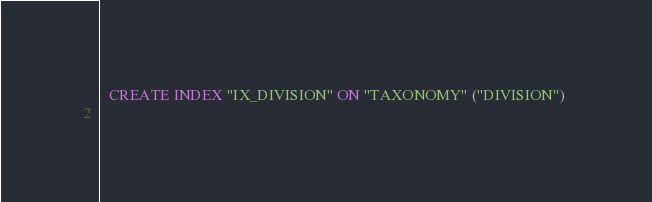Convert code to text. <code><loc_0><loc_0><loc_500><loc_500><_SQL_>
  CREATE INDEX "IX_DIVISION" ON "TAXONOMY" ("DIVISION") 
  </code> 